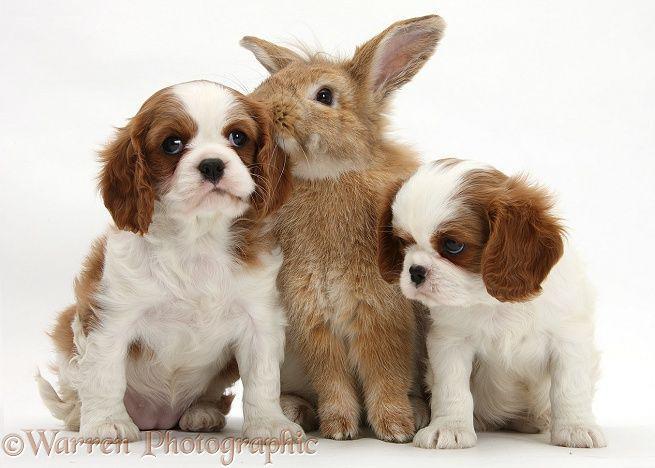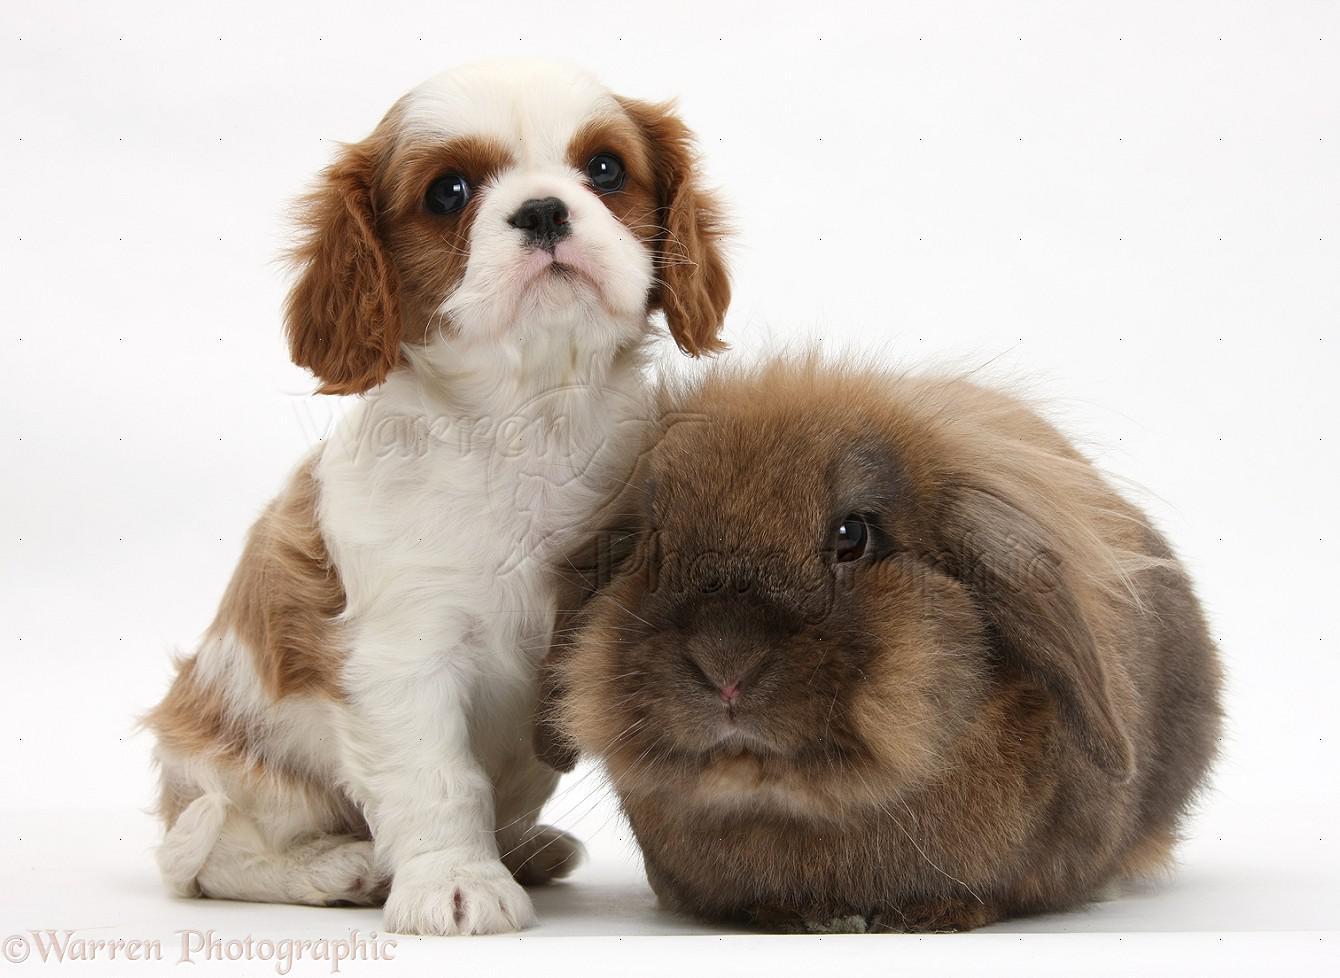The first image is the image on the left, the second image is the image on the right. Analyze the images presented: Is the assertion "A rabbit is between two puppies in one image." valid? Answer yes or no. Yes. The first image is the image on the left, the second image is the image on the right. For the images displayed, is the sentence "In one of the images, a brown rabbit is in between two white and brown cocker spaniel puppies" factually correct? Answer yes or no. Yes. 